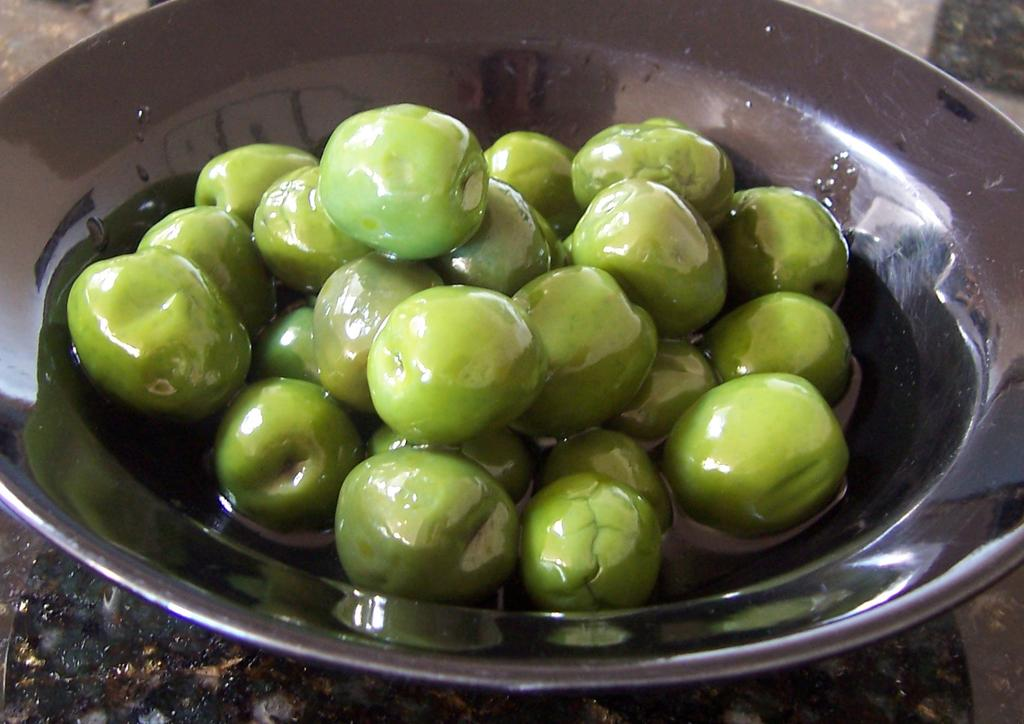What type of food is visible in the image? There are green olives in the image. What is the color of the plate on which the green olives are placed? The green olives are on a black plate. How close is the view of the green olives and the black plate in the image? The image provides a close view of the green olives and the black plate. What type of jelly can be seen on the coast in the image? There is no jelly or coast present in the image; it only features green olives on a black plate. 